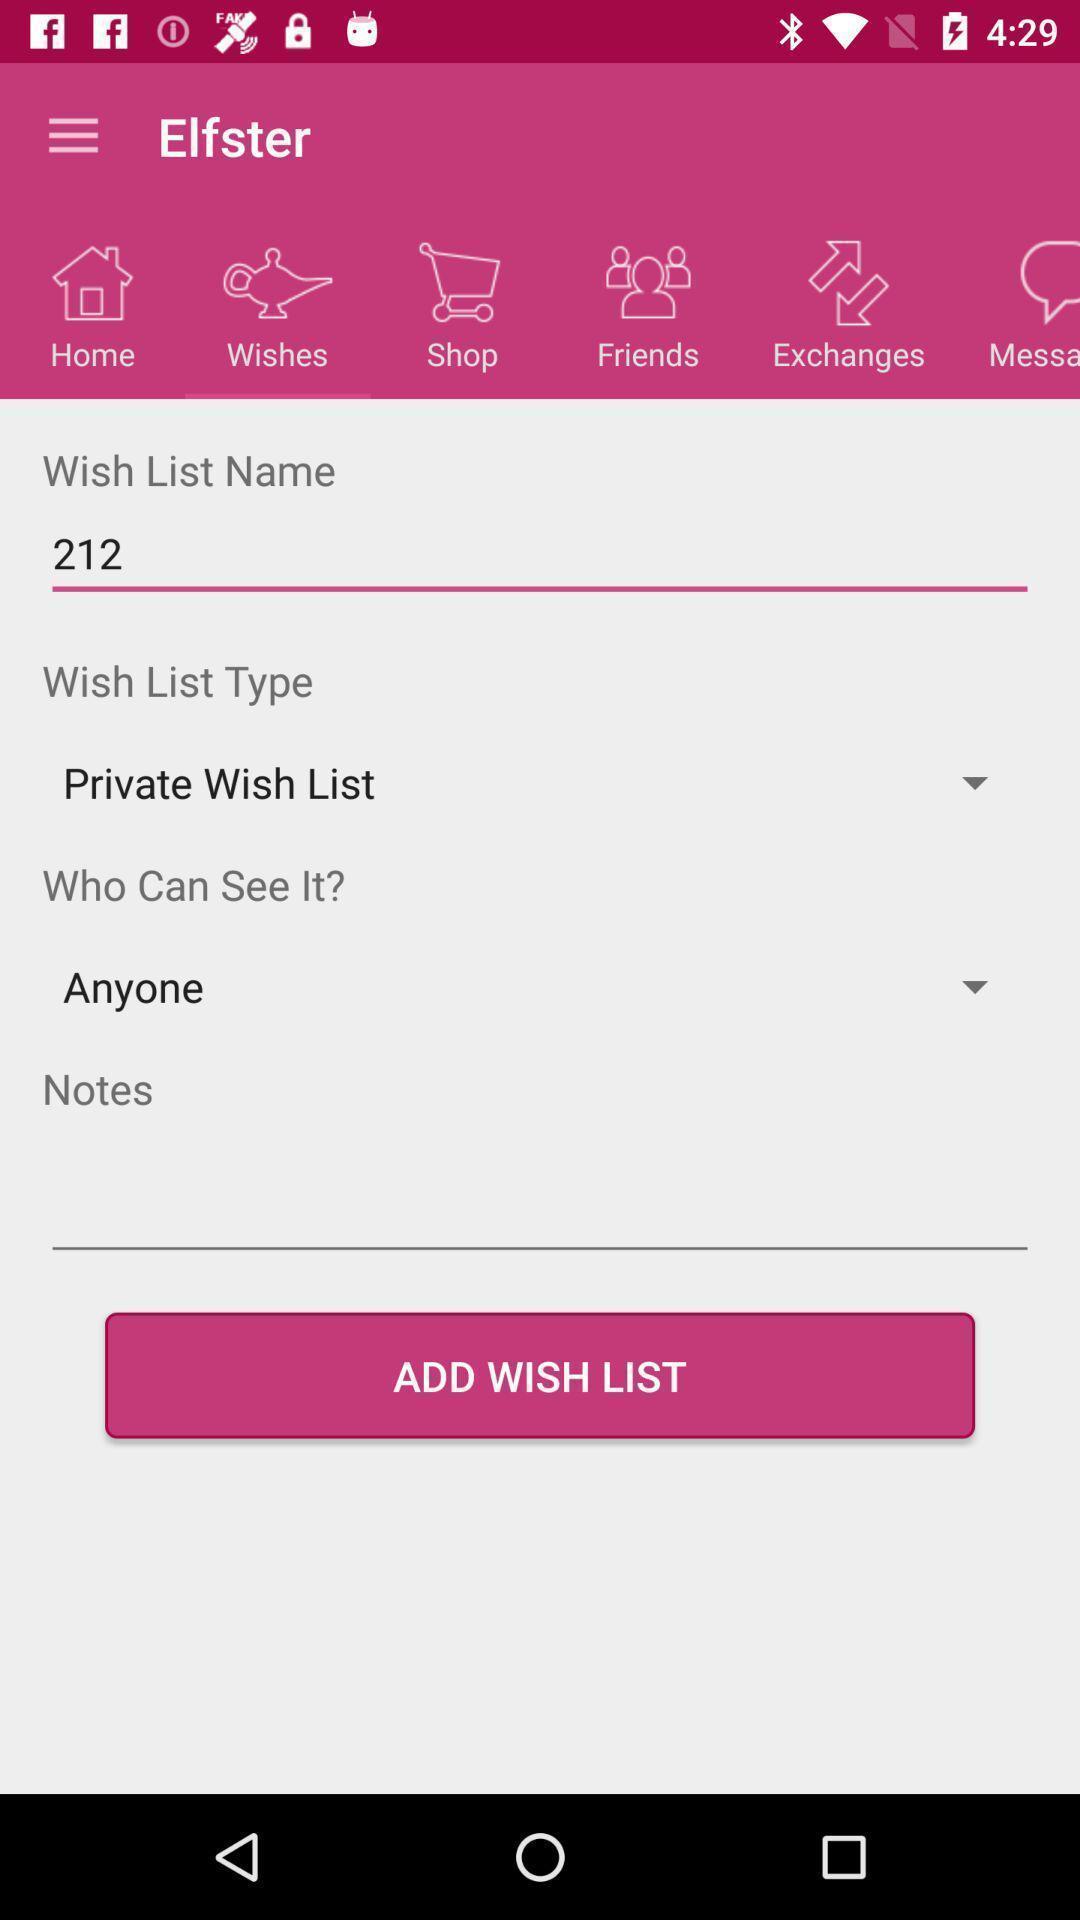Describe this image in words. Page to add wishlist in app. 